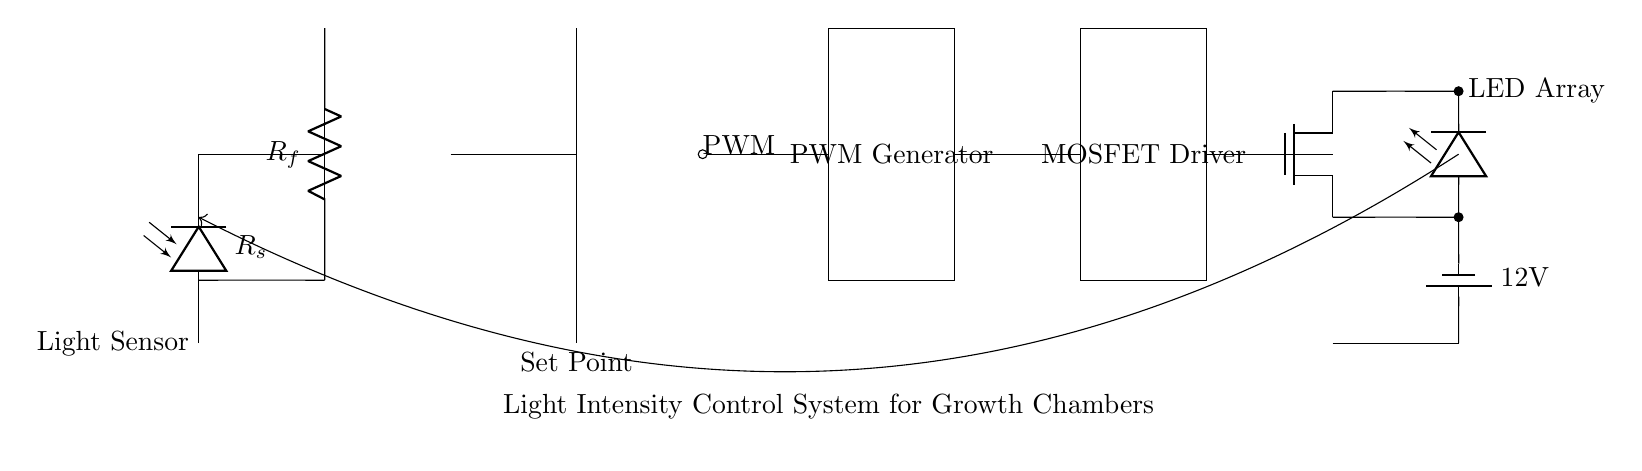What is the main purpose of this circuit? The main purpose of this circuit is to control light intensity to simulate various daylight conditions in growth chambers. This is indicated by the overall labeling and function of various components such as the light sensor, PWM generator, and LED array.
Answer: light intensity control What type of light sensor is used in this circuit? The light sensor used in this circuit is a photodiode, which is depicted as a component labeled "Light Sensor" in the diagram. Photodiodes are commonly used to detect light intensity.
Answer: photodiode What is the role of the PWM generator in this circuit? The PWM (Pulse Width Modulation) generator modulates the power supplied to the LED array by adjusting the duty cycle of the PWM signal, controlling the brightness of the LEDs based on the light intensity measurements. This function is crucial for achieving varying light conditions.
Answer: modulates LED power What component prevents overload in the LED array? The MOSFET acts as a switch that regulates the current flowing to the LED array, thereby preventing overload by allowing only the necessary current to pass through based on the PWM signal. This ensures safe operation and control of the LEDs.
Answer: MOSFET How is feedback implemented in this circuit? Feedback is implemented by the connection from the LED array output back to the light sensor, which allows the system to adjust the voltage and current based on the measured light intensity. This creates a closed-loop control system that maintains desired lighting conditions.
Answer: feedback loop What is the set point in this system? The set point in this system is the voltage level at the comparator stage, where it is compared to the output from the light sensor. This set point determines the desired light intensity that the system aims to maintain.
Answer: Set Point What does the resistor Rf do in this circuit? The resistor Rf is used in the feedback configuration of the operational amplifier, likely to set gain or provide stability in the amplifier circuit, parameters crucial for accurate light intensity measurement and control.
Answer: sets amplifier gain 